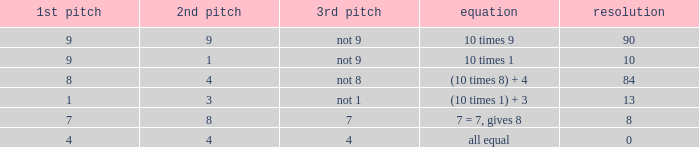If the equation is (10 times 1) + 3, what is the 2nd throw? 3.0. 